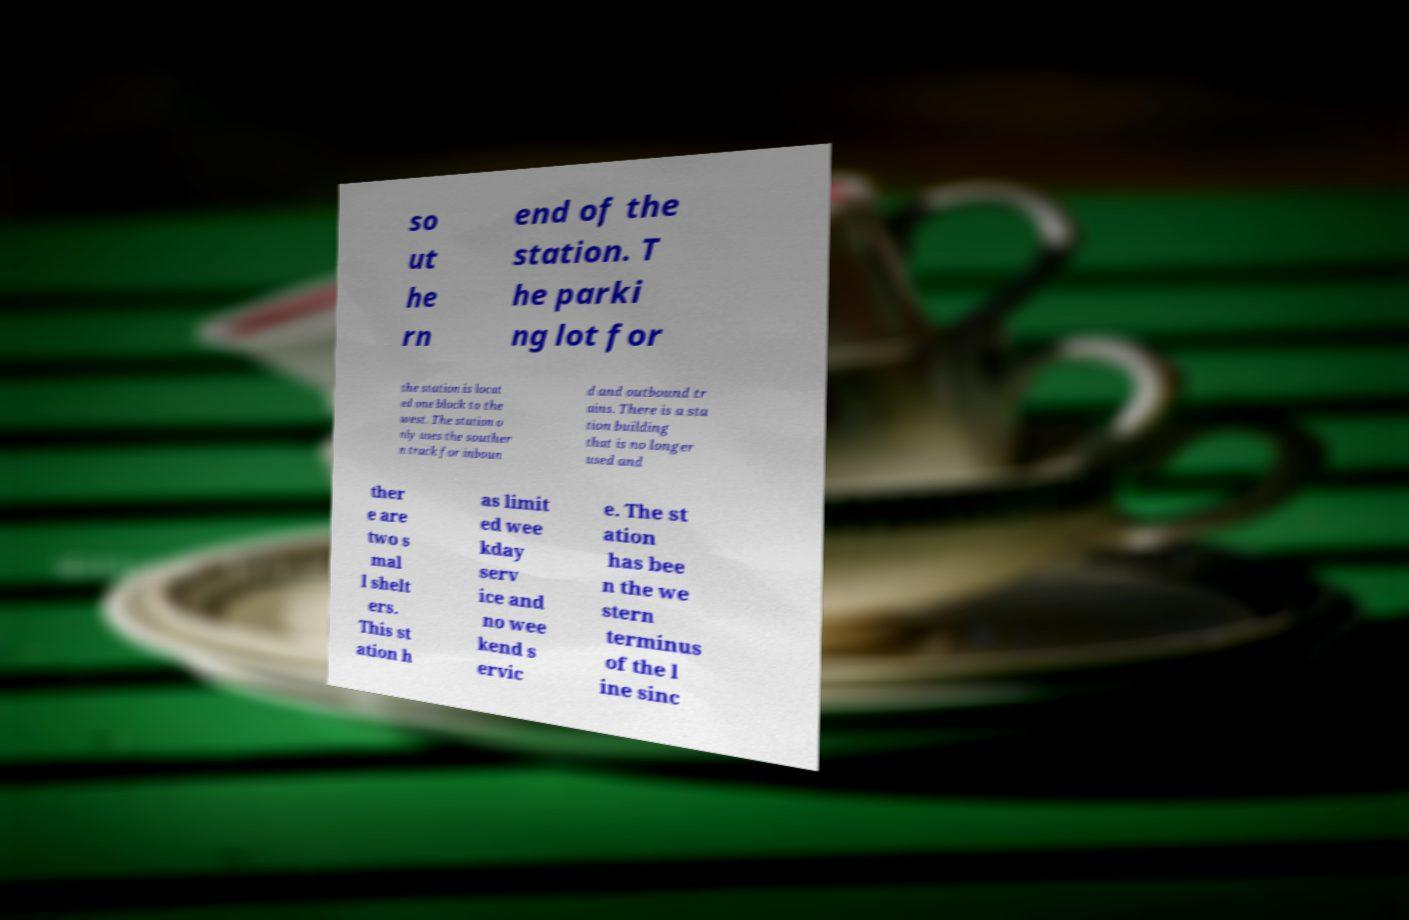Please identify and transcribe the text found in this image. so ut he rn end of the station. T he parki ng lot for the station is locat ed one block to the west. The station o nly uses the souther n track for inboun d and outbound tr ains. There is a sta tion building that is no longer used and ther e are two s mal l shelt ers. This st ation h as limit ed wee kday serv ice and no wee kend s ervic e. The st ation has bee n the we stern terminus of the l ine sinc 